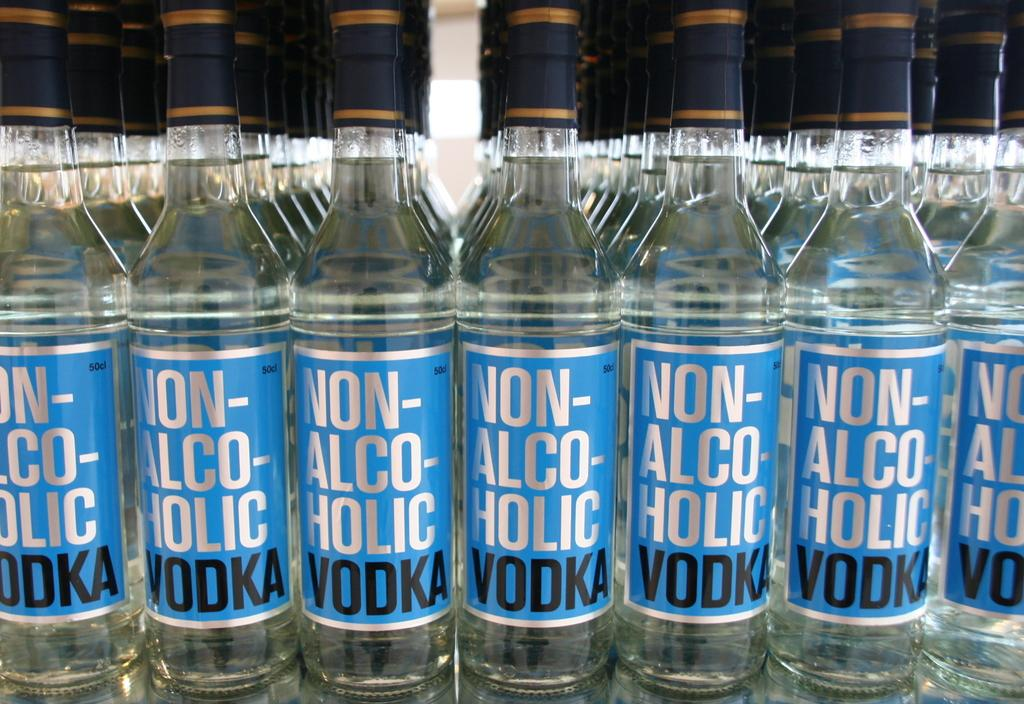<image>
Relay a brief, clear account of the picture shown. Lots of bottles of Non-Alcoholic Vodka are grouped together. 